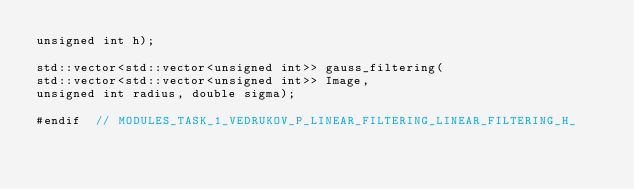<code> <loc_0><loc_0><loc_500><loc_500><_C_>unsigned int h);

std::vector<std::vector<unsigned int>> gauss_filtering(
std::vector<std::vector<unsigned int>> Image,
unsigned int radius, double sigma);

#endif  // MODULES_TASK_1_VEDRUKOV_P_LINEAR_FILTERING_LINEAR_FILTERING_H_
</code> 